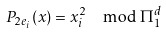<formula> <loc_0><loc_0><loc_500><loc_500>P _ { 2 e _ { i } } ( x ) = x _ { i } ^ { 2 } \mod \Pi ^ { d } _ { 1 }</formula> 